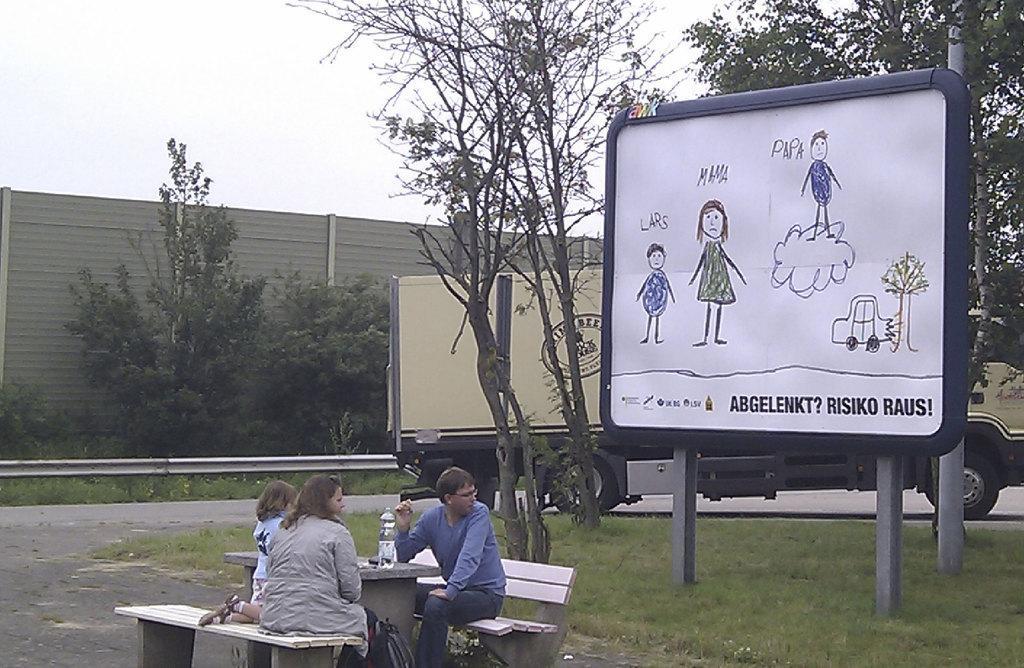Describe this image in one or two sentences. This is an outside view. On the right side there is a board on which I can see some text and drawings. On the ground, I can see the grass. At the bottom there is a woman, a man and a baby are sitting on the benches. There is a bottle on the table. Beside the table there is a bag placed on the ground. In the background there is a truck and a wall and also there are many trees. At the top of the image I can see the sky. 